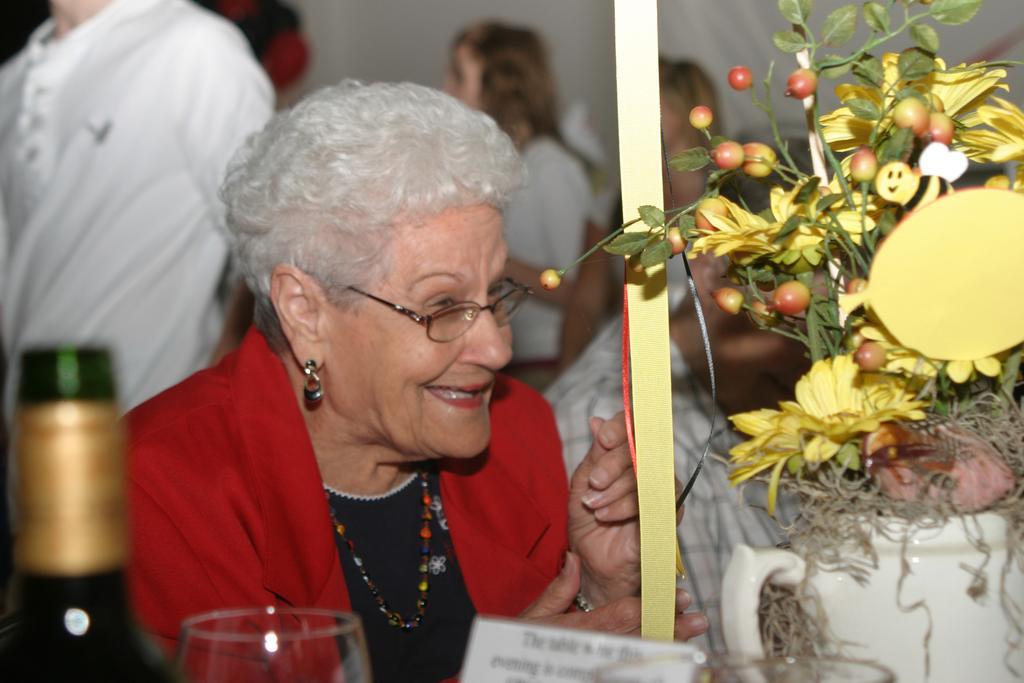In one or two sentences, can you explain what this image depicts? On the right side of the image we can see one yellow color object and one pot with a plant, fruits and flowers. At the bottom of the image, we can see some objects. In the center of the image we can see a person is smiling. In front of her, there is an object. In the background there is a wall and a few people. 